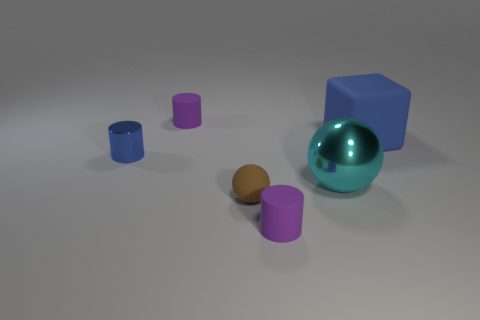Subtract all matte cylinders. How many cylinders are left? 1 Subtract all cyan balls. How many balls are left? 1 Add 1 purple cylinders. How many objects exist? 7 Subtract all cubes. How many objects are left? 5 Subtract all big brown matte cubes. Subtract all big cyan metal spheres. How many objects are left? 5 Add 4 small blue cylinders. How many small blue cylinders are left? 5 Add 4 tiny cyan cylinders. How many tiny cyan cylinders exist? 4 Subtract 0 purple blocks. How many objects are left? 6 Subtract 1 cylinders. How many cylinders are left? 2 Subtract all blue cylinders. Subtract all purple balls. How many cylinders are left? 2 